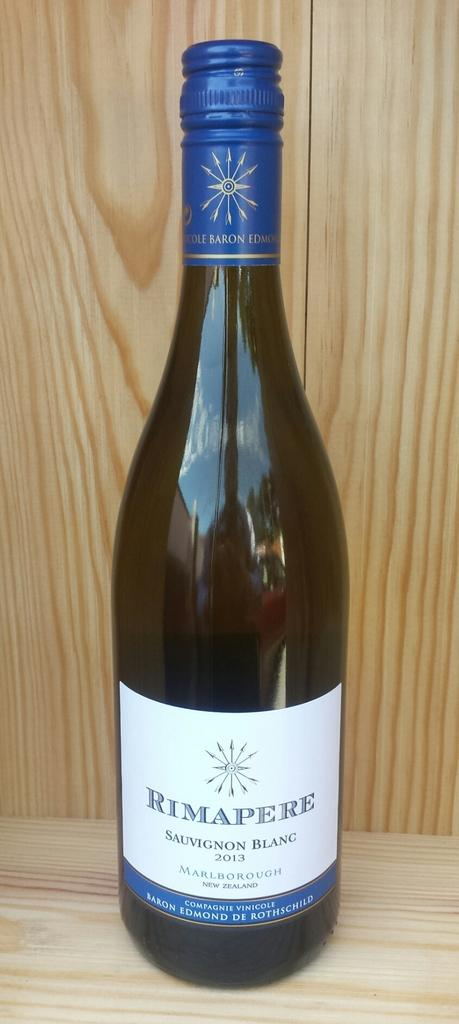<image>
Provide a brief description of the given image. An unopened bottle of sauvignon blanc wine with blue foil. 